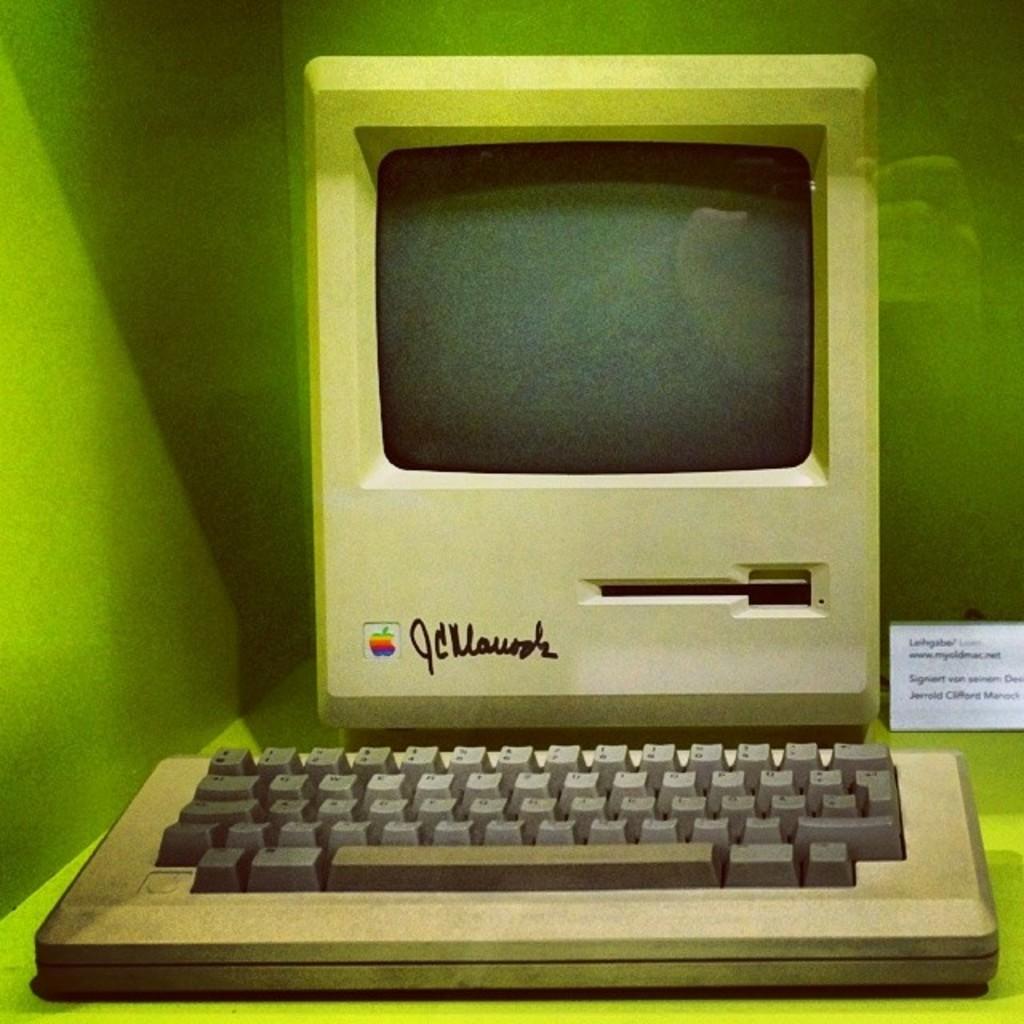What brand is this computer?
Your answer should be compact. Apple. 